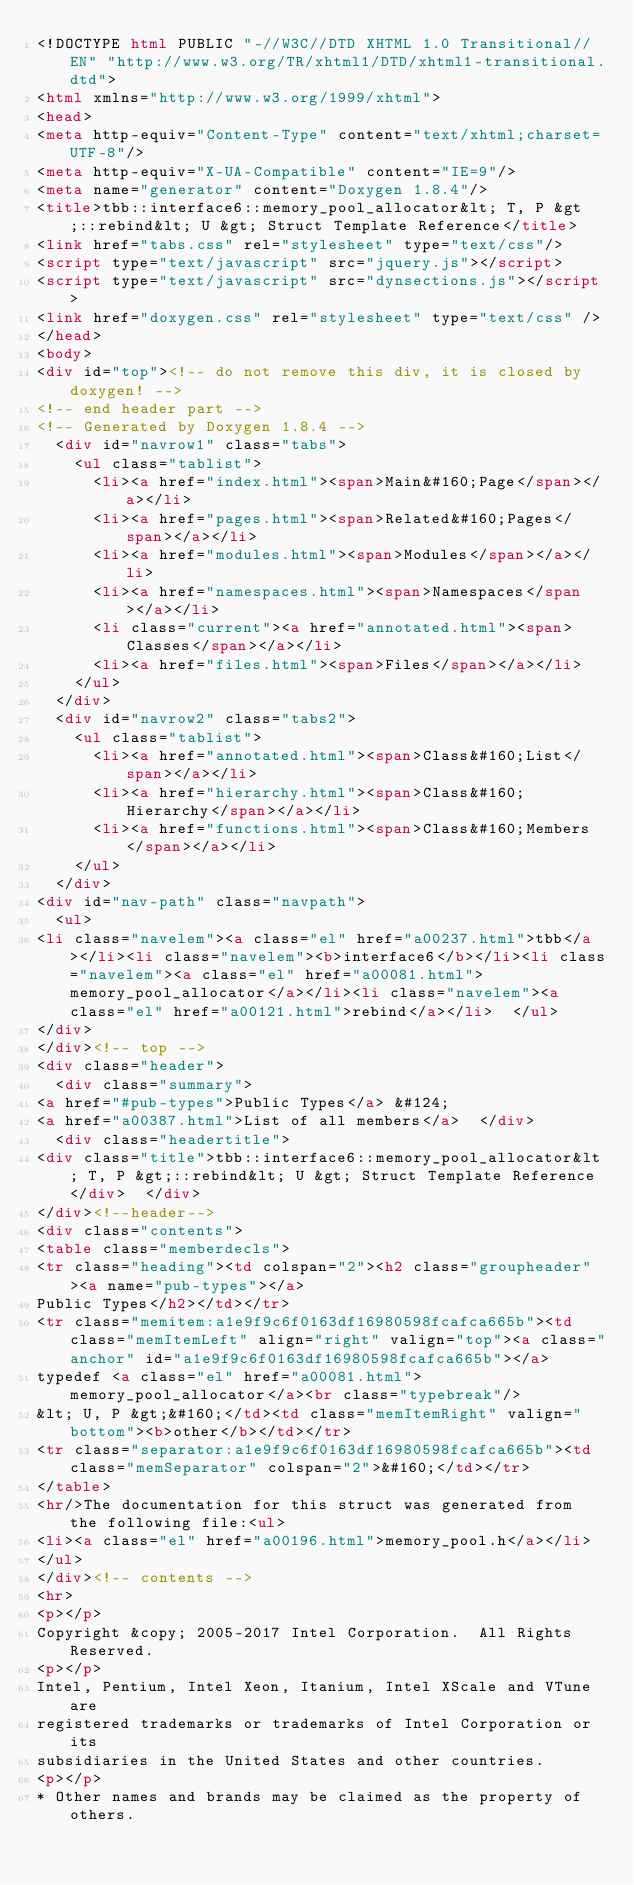Convert code to text. <code><loc_0><loc_0><loc_500><loc_500><_HTML_><!DOCTYPE html PUBLIC "-//W3C//DTD XHTML 1.0 Transitional//EN" "http://www.w3.org/TR/xhtml1/DTD/xhtml1-transitional.dtd">
<html xmlns="http://www.w3.org/1999/xhtml">
<head>
<meta http-equiv="Content-Type" content="text/xhtml;charset=UTF-8"/>
<meta http-equiv="X-UA-Compatible" content="IE=9"/>
<meta name="generator" content="Doxygen 1.8.4"/>
<title>tbb::interface6::memory_pool_allocator&lt; T, P &gt;::rebind&lt; U &gt; Struct Template Reference</title>
<link href="tabs.css" rel="stylesheet" type="text/css"/>
<script type="text/javascript" src="jquery.js"></script>
<script type="text/javascript" src="dynsections.js"></script>
<link href="doxygen.css" rel="stylesheet" type="text/css" />
</head>
<body>
<div id="top"><!-- do not remove this div, it is closed by doxygen! -->
<!-- end header part -->
<!-- Generated by Doxygen 1.8.4 -->
  <div id="navrow1" class="tabs">
    <ul class="tablist">
      <li><a href="index.html"><span>Main&#160;Page</span></a></li>
      <li><a href="pages.html"><span>Related&#160;Pages</span></a></li>
      <li><a href="modules.html"><span>Modules</span></a></li>
      <li><a href="namespaces.html"><span>Namespaces</span></a></li>
      <li class="current"><a href="annotated.html"><span>Classes</span></a></li>
      <li><a href="files.html"><span>Files</span></a></li>
    </ul>
  </div>
  <div id="navrow2" class="tabs2">
    <ul class="tablist">
      <li><a href="annotated.html"><span>Class&#160;List</span></a></li>
      <li><a href="hierarchy.html"><span>Class&#160;Hierarchy</span></a></li>
      <li><a href="functions.html"><span>Class&#160;Members</span></a></li>
    </ul>
  </div>
<div id="nav-path" class="navpath">
  <ul>
<li class="navelem"><a class="el" href="a00237.html">tbb</a></li><li class="navelem"><b>interface6</b></li><li class="navelem"><a class="el" href="a00081.html">memory_pool_allocator</a></li><li class="navelem"><a class="el" href="a00121.html">rebind</a></li>  </ul>
</div>
</div><!-- top -->
<div class="header">
  <div class="summary">
<a href="#pub-types">Public Types</a> &#124;
<a href="a00387.html">List of all members</a>  </div>
  <div class="headertitle">
<div class="title">tbb::interface6::memory_pool_allocator&lt; T, P &gt;::rebind&lt; U &gt; Struct Template Reference</div>  </div>
</div><!--header-->
<div class="contents">
<table class="memberdecls">
<tr class="heading"><td colspan="2"><h2 class="groupheader"><a name="pub-types"></a>
Public Types</h2></td></tr>
<tr class="memitem:a1e9f9c6f0163df16980598fcafca665b"><td class="memItemLeft" align="right" valign="top"><a class="anchor" id="a1e9f9c6f0163df16980598fcafca665b"></a>
typedef <a class="el" href="a00081.html">memory_pool_allocator</a><br class="typebreak"/>
&lt; U, P &gt;&#160;</td><td class="memItemRight" valign="bottom"><b>other</b></td></tr>
<tr class="separator:a1e9f9c6f0163df16980598fcafca665b"><td class="memSeparator" colspan="2">&#160;</td></tr>
</table>
<hr/>The documentation for this struct was generated from the following file:<ul>
<li><a class="el" href="a00196.html">memory_pool.h</a></li>
</ul>
</div><!-- contents -->
<hr>
<p></p>
Copyright &copy; 2005-2017 Intel Corporation.  All Rights Reserved.
<p></p>
Intel, Pentium, Intel Xeon, Itanium, Intel XScale and VTune are
registered trademarks or trademarks of Intel Corporation or its
subsidiaries in the United States and other countries.
<p></p>
* Other names and brands may be claimed as the property of others.
</code> 